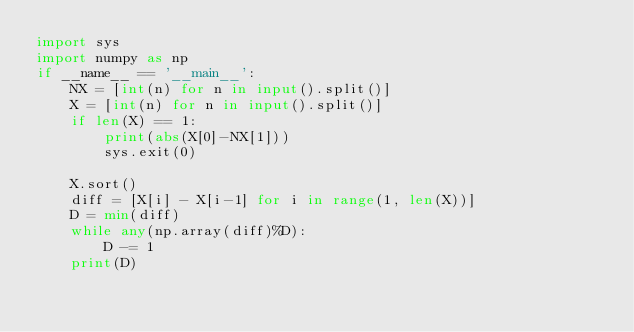<code> <loc_0><loc_0><loc_500><loc_500><_Python_>import sys
import numpy as np
if __name__ == '__main__':
    NX = [int(n) for n in input().split()]
    X = [int(n) for n in input().split()]
    if len(X) == 1:
        print(abs(X[0]-NX[1]))
        sys.exit(0)

    X.sort()
    diff = [X[i] - X[i-1] for i in range(1, len(X))]
    D = min(diff)
    while any(np.array(diff)%D):
        D -= 1
    print(D)</code> 